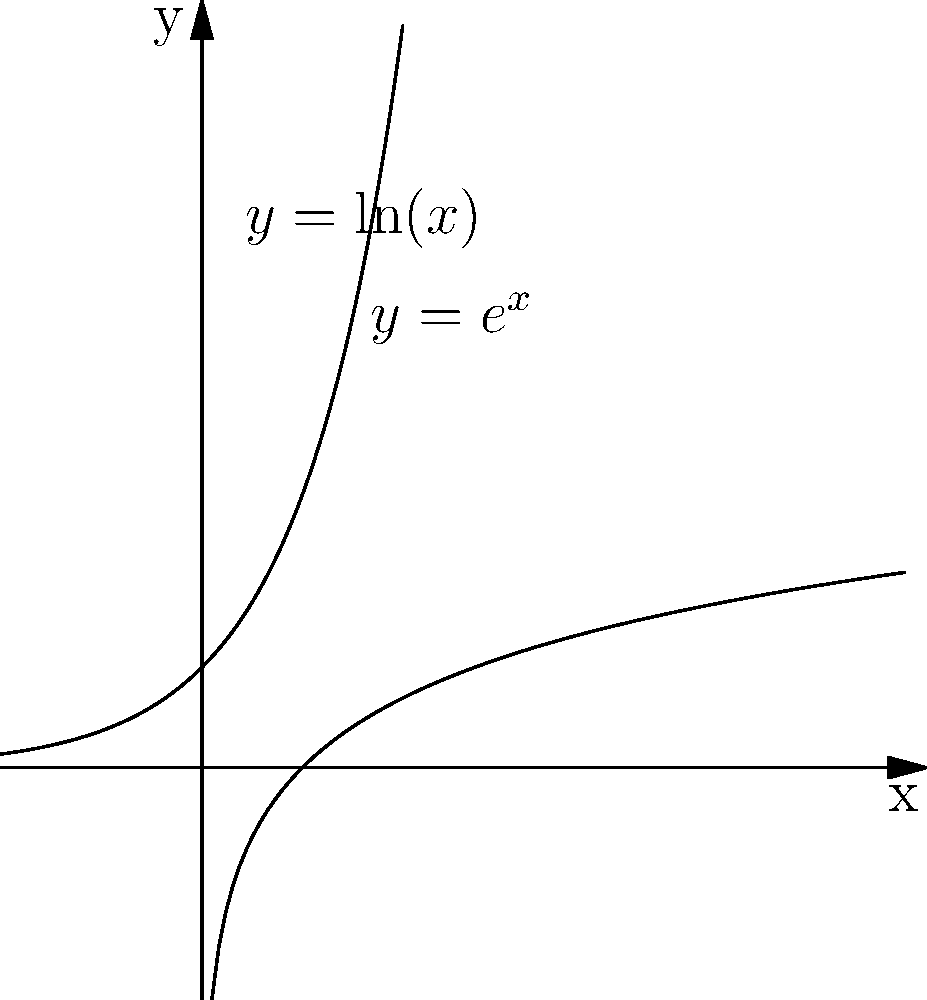Consider the fractal-like branching patterns of neurons and their similarity to mathematical functions. In the graph above, which function better represents the exponential growth pattern often observed in dendritic branching, and how does this relate to the concept of self-similarity in fractals? To answer this question, let's break it down step-by-step:

1. Observe the two functions plotted:
   - The curve that starts below the x-axis and curves upward is $y = e^x$ (exponential function)
   - The curve that starts at the y-axis and grows more slowly is $y = \ln(x)$ (natural logarithm function)

2. Dendritic branching in neurons often exhibits exponential growth:
   - As you move away from the cell body, the number of branches tends to increase rapidly
   - This pattern is more closely represented by the exponential function $y = e^x$

3. The exponential function and fractal self-similarity:
   - Fractals are characterized by self-similarity at different scales
   - The exponential function has a unique property: $\frac{d}{dx}e^x = e^x$
   - This means that the rate of change of $e^x$ is proportional to itself at every point

4. Relating to dendritic branching:
   - As dendrites branch, each new branch point can potentially give rise to multiple new branches
   - This cascading effect leads to an exponential increase in complexity
   - The self-similar nature of this branching is analogous to fractal patterns

5. Logarithmic function vs. Exponential function:
   - While the logarithmic function ($y = \ln(x)$) grows, it does so at a decreasing rate
   - This is unlike the ever-increasing growth rate of dendritic branching

Therefore, the exponential function $y = e^x$ better represents the growth pattern of dendritic branching, and its self-similar rate of change property relates to the concept of self-similarity in fractals.
Answer: $y = e^x$; exponential growth mimics dendritic branching and exhibits self-similarity like fractals. 